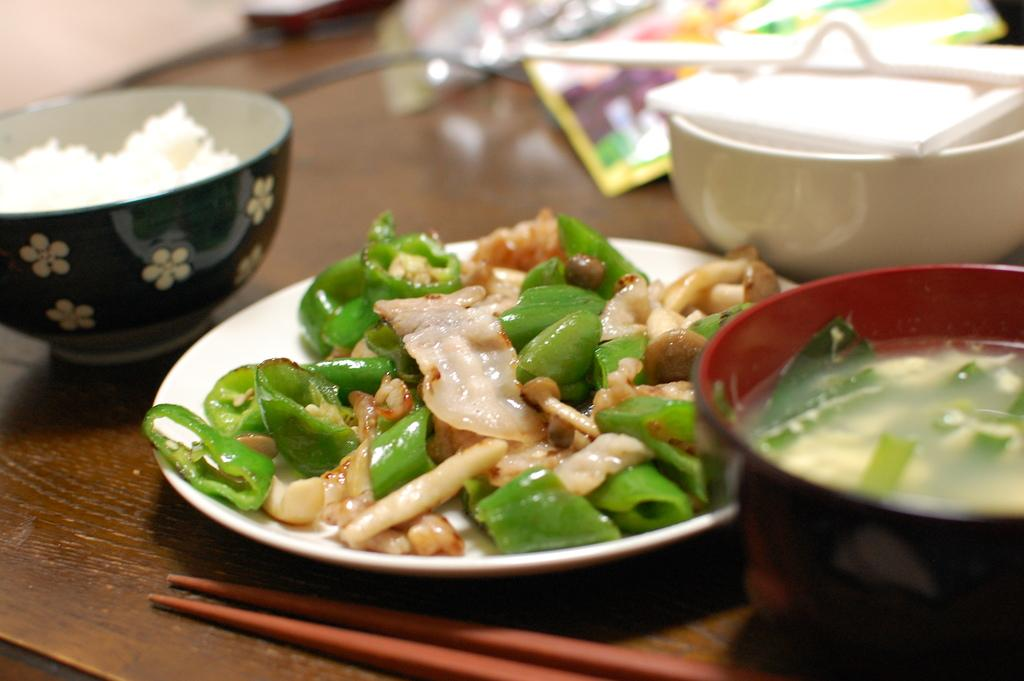What is present on the plate in the image? There are food items in the plate. What is present in the bowl in the image? There are food items in the bowl. What can be seen on top of the bowl in the image? There are objects on the bowl. What type of flesh can be seen in the image? There is no flesh present in the image; it features food items in a plate and a bowl. What account number is associated with the food items in the image? There is no account number associated with the food items in the image. 